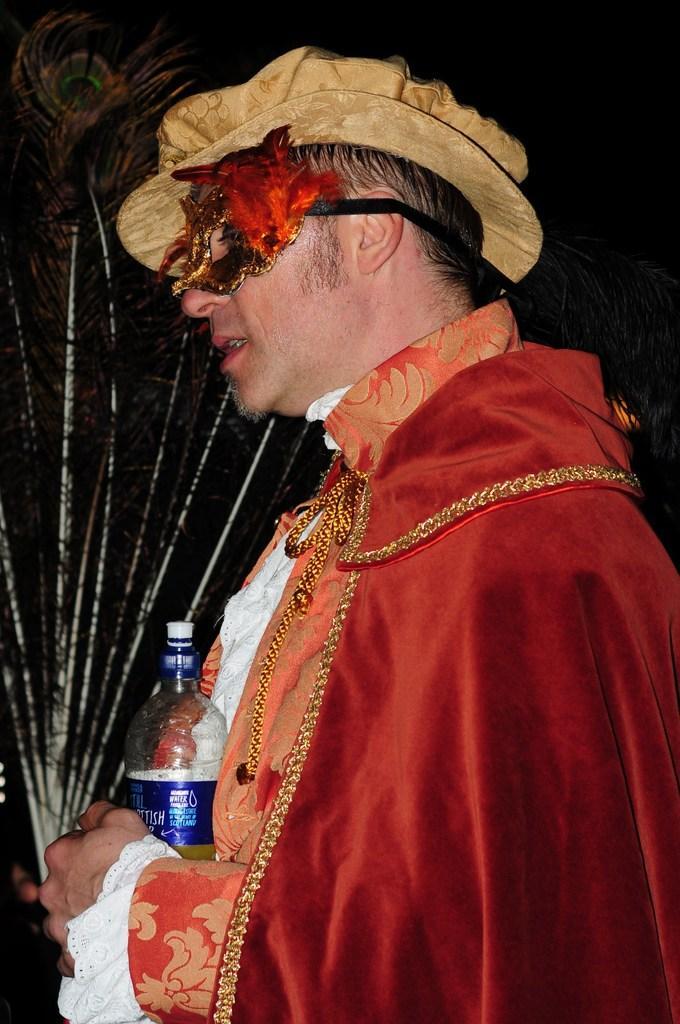Can you describe this image briefly? In this image, we can see a person wearing clothes and hat. This person is holding a bottle and peacock feathers with his hands. 